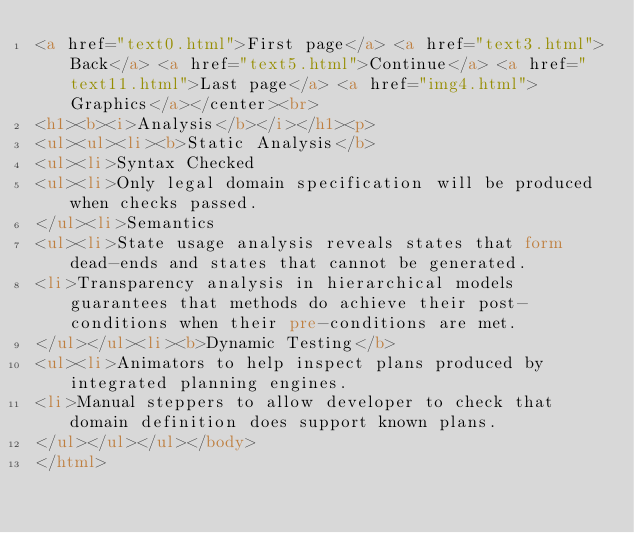<code> <loc_0><loc_0><loc_500><loc_500><_HTML_><a href="text0.html">First page</a> <a href="text3.html">Back</a> <a href="text5.html">Continue</a> <a href="text11.html">Last page</a> <a href="img4.html">Graphics</a></center><br>
<h1><b><i>Analysis</b></i></h1><p>
<ul><ul><li><b>Static Analysis</b>
<ul><li>Syntax Checked
<ul><li>Only legal domain specification will be produced when checks passed.
</ul><li>Semantics
<ul><li>State usage analysis reveals states that form dead-ends and states that cannot be generated.
<li>Transparency analysis in hierarchical models guarantees that methods do achieve their post-conditions when their pre-conditions are met.
</ul></ul><li><b>Dynamic Testing</b>
<ul><li>Animators to help inspect plans produced by integrated planning engines.
<li>Manual steppers to allow developer to check that domain definition does support known plans.  
</ul></ul></ul></body>
</html></code> 